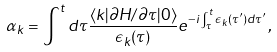<formula> <loc_0><loc_0><loc_500><loc_500>\alpha _ { k } = \int ^ { t } d \tau \frac { \langle k | \partial H / \partial \tau | 0 \rangle } { \epsilon _ { k } ( \tau ) } e ^ { - i \int ^ { t } _ { \tau } \epsilon _ { k } ( \tau ^ { \prime } ) d \tau ^ { \prime } } \, ,</formula> 